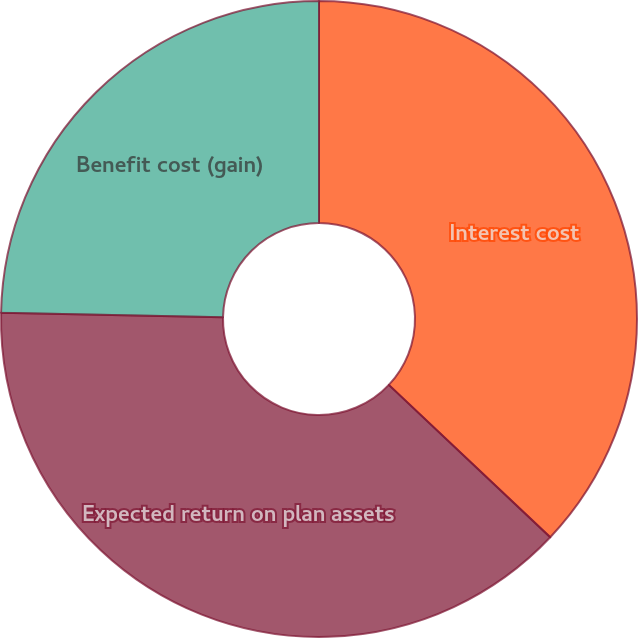<chart> <loc_0><loc_0><loc_500><loc_500><pie_chart><fcel>Interest cost<fcel>Expected return on plan assets<fcel>Benefit cost (gain)<nl><fcel>37.04%<fcel>38.27%<fcel>24.69%<nl></chart> 